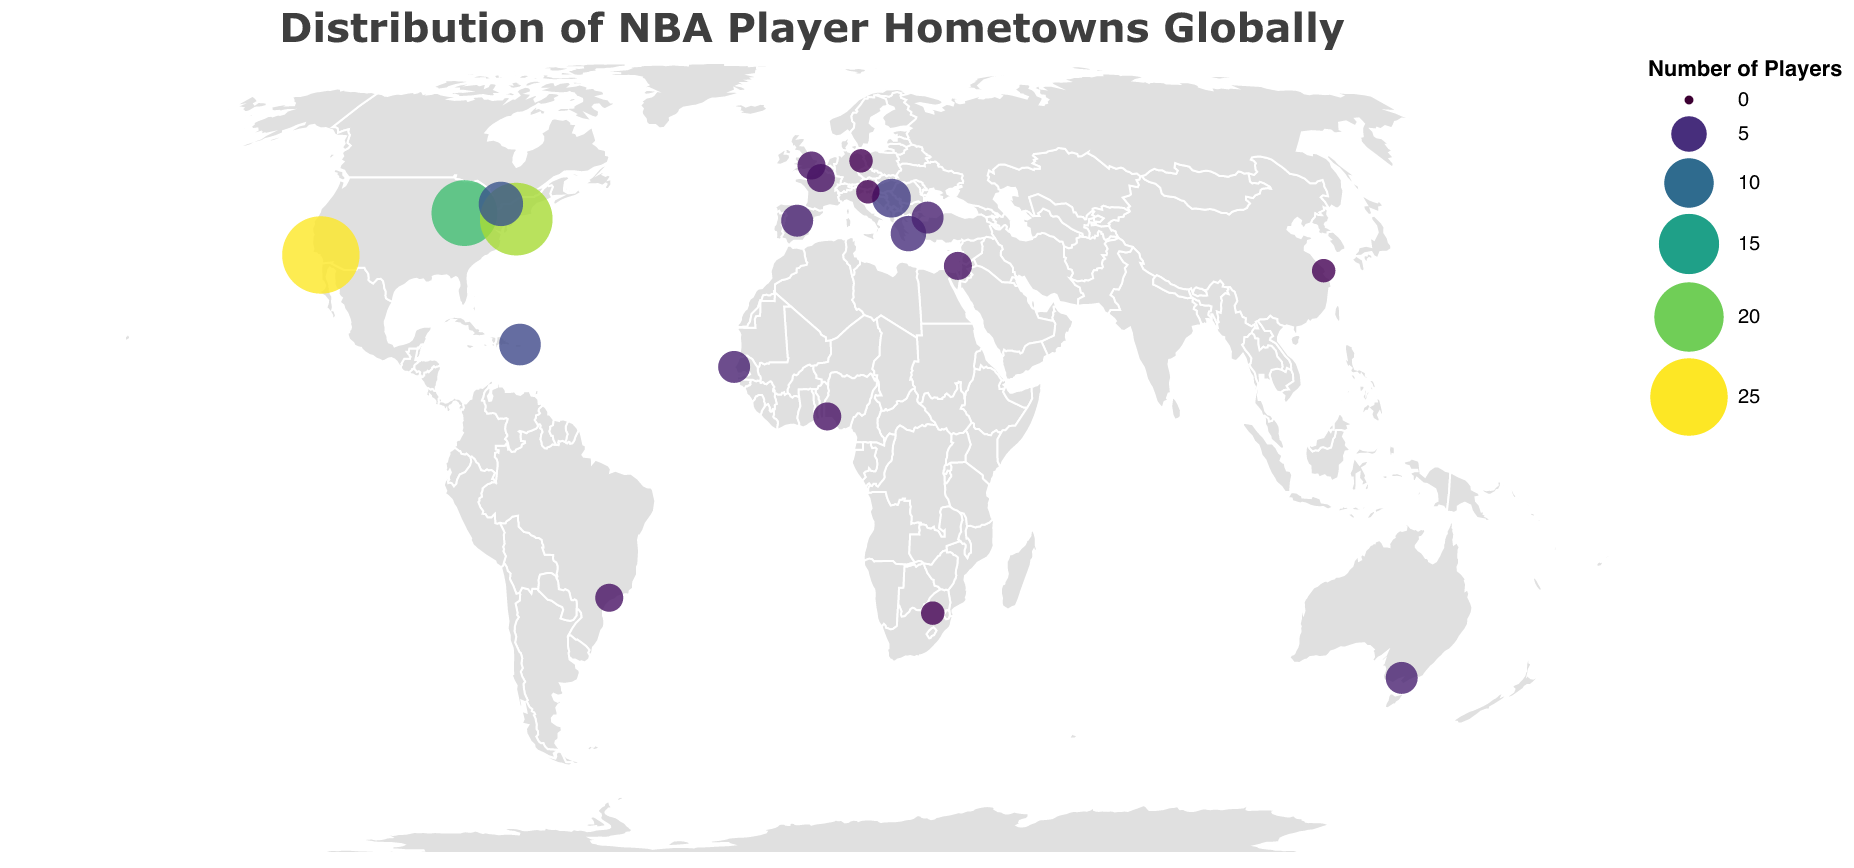Which city has produced the most NBA players according to the figure? The city with the largest circle represents the highest number of players. Los Angeles has the largest circle with 25 players.
Answer: Los Angeles How many cities are represented in the figure? Counting the number of unique cities provided in the data, we see there are 20 cities in total.
Answer: 20 What is the title of the figure? The title is displayed at the top of the figure. It reads "Distribution of NBA Player Hometowns Globally".
Answer: Distribution of NBA Player Hometowns Globally Which country outside the USA has the highest number of NBA player hometowns? By evaluating the counts of players from non-USA cities, Toronto in Canada has the highest number with 8 players.
Answer: Canada How does the number of NBA players from Chicago compare to those from New York City? By comparing the counts for each city, Chicago has 18 players while New York City has 22 players. New York City has 4 more players than Chicago.
Answer: New York City is 4 more What is the total number of NBA players from Europe represented in the figure? Summing the counts for European cities: Belgrade (6), Athens (5), Madrid (4), Paris (3), Berlin (2), Istanbul (4), Ljubljana (2). Total: 6+5+4+3+2+4+2 = 26.
Answer: 26 Which cities in Africa are shown on the figure and how many players come from each? The figure shows two cities in Africa: Lagos with 3 players and Dakar with 4 players.
Answer: Lagos: 3, Dakar: 4 Are there any cities that have produced the same number of NBA players? If yes, which ones? By examining the data, we see multiple pairs with the same count: Melbourne and Madrid (4 each), Lagos, Sao Paulo, and Paris (3 each), Johannesburg, Shanghai, Berlin, and Ljubljana (2 each).
Answer: Yes What is the average number of NBA players from the cities listed in the USA? Summing up the counts for the US cities (Los Angeles: 25, Chicago: 18, New York City: 22) and dividing by the number of cities (3): (25+18+22)/3 = 65/3 ≈ 21.67.
Answer: ~21.67 How does the distribution of player hometowns differ between North America and Asia? North America has: Los Angeles (25), Chicago (18), New York City (22), Toronto (8), San Juan (7). Total: 80 players. Asia has: Shanghai (2), Tel Aviv (3). Total: 5 players. Thus, North America has markedly more players.
Answer: North America has markedly more 